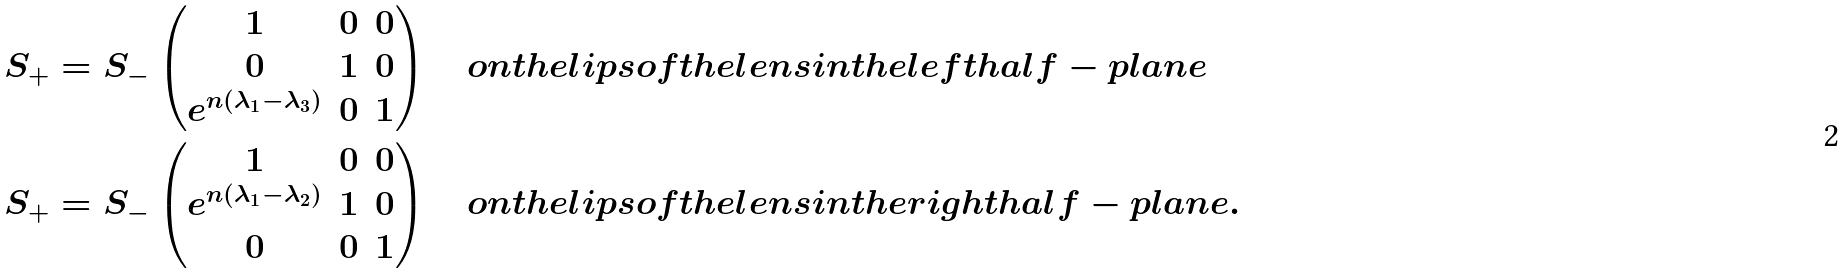Convert formula to latex. <formula><loc_0><loc_0><loc_500><loc_500>S _ { + } & = S _ { - } \begin{pmatrix} 1 & 0 & 0 \\ 0 & 1 & 0 \\ e ^ { n ( \lambda _ { 1 } - \lambda _ { 3 } ) } & 0 & 1 \end{pmatrix} \quad o n t h e l i p s o f t h e l e n s i n t h e l e f t h a l f - p l a n e \\ S _ { + } & = S _ { - } \begin{pmatrix} 1 & 0 & 0 \\ e ^ { n ( \lambda _ { 1 } - \lambda _ { 2 } ) } & 1 & 0 \\ 0 & 0 & 1 \end{pmatrix} \quad o n t h e l i p s o f t h e l e n s i n t h e r i g h t h a l f - p l a n e .</formula> 